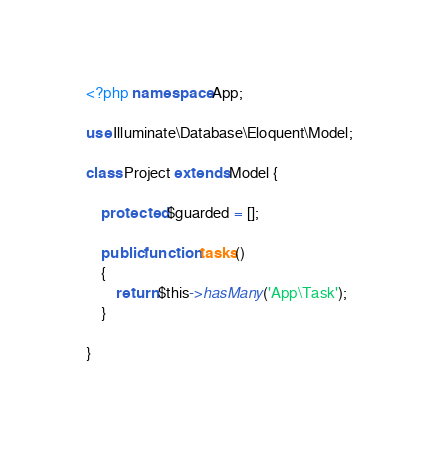<code> <loc_0><loc_0><loc_500><loc_500><_PHP_><?php namespace App;

use Illuminate\Database\Eloquent\Model;

class Project extends Model {

    protected $guarded = [];

    public function tasks()
    {
        return $this->hasMany('App\Task');
    }

}</code> 